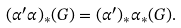Convert formula to latex. <formula><loc_0><loc_0><loc_500><loc_500>( \alpha ^ { \prime } \alpha ) _ { * } ( G ) = ( \alpha ^ { \prime } ) _ { * } \alpha _ { * } ( G ) .</formula> 